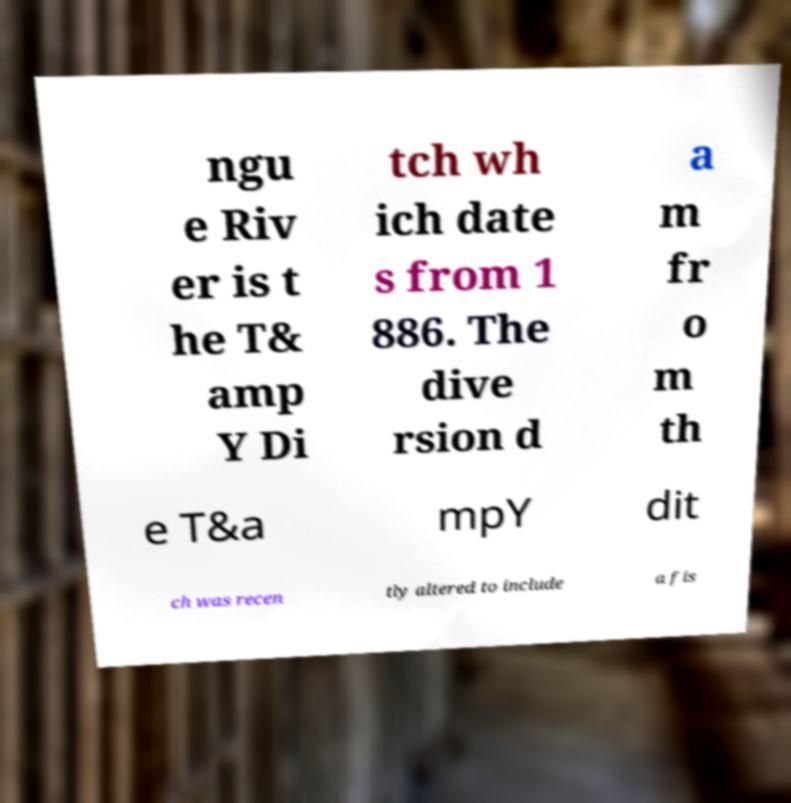Could you extract and type out the text from this image? ngu e Riv er is t he T& amp Y Di tch wh ich date s from 1 886. The dive rsion d a m fr o m th e T&a mpY dit ch was recen tly altered to include a fis 